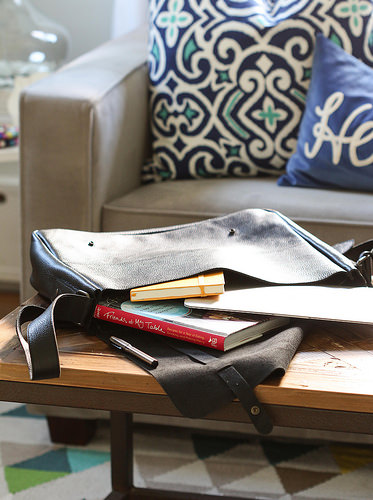<image>
Can you confirm if the book is on the couch? No. The book is not positioned on the couch. They may be near each other, but the book is not supported by or resting on top of the couch. 